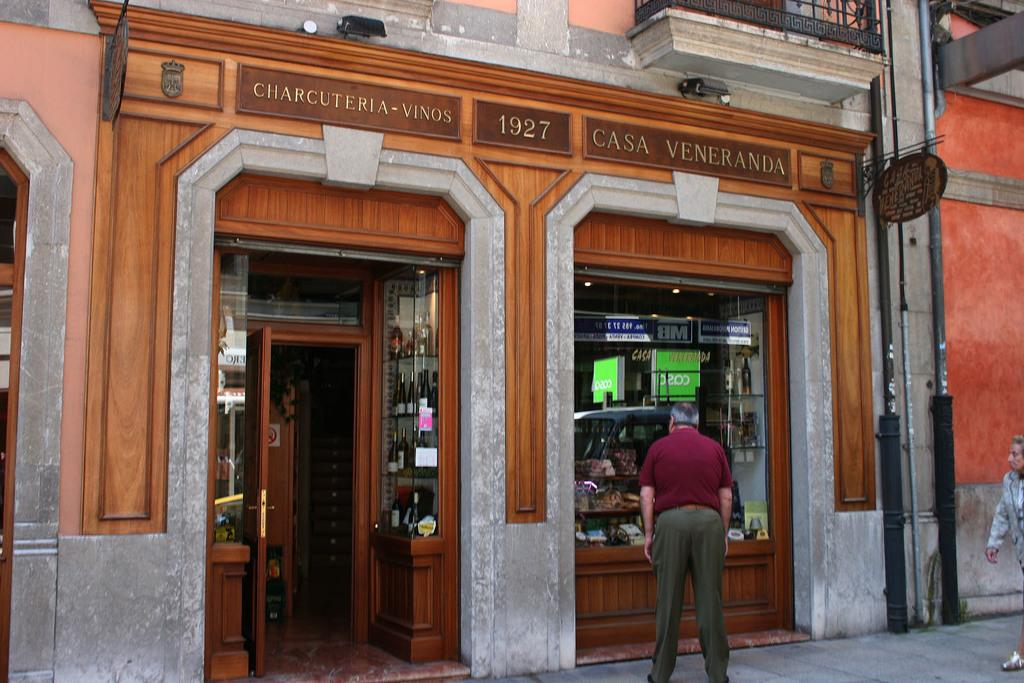<image>
Create a compact narrative representing the image presented. A man is looking into the window of Casa Veneranda. 